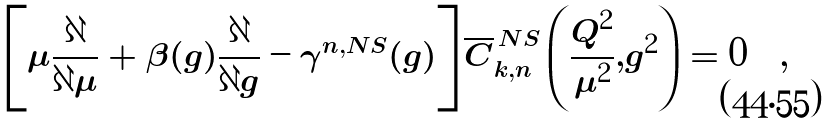Convert formula to latex. <formula><loc_0><loc_0><loc_500><loc_500>\left [ \mu \frac { \partial } { \partial \mu } + \beta ( g ) \frac { \partial } { \partial g } - \gamma ^ { n , N S } ( g ) \right ] \overline { C } _ { k , n } ^ { \, N S } \left ( \frac { Q ^ { 2 } } { \mu ^ { 2 } } , g ^ { 2 } \right ) = 0 \quad ,</formula> 